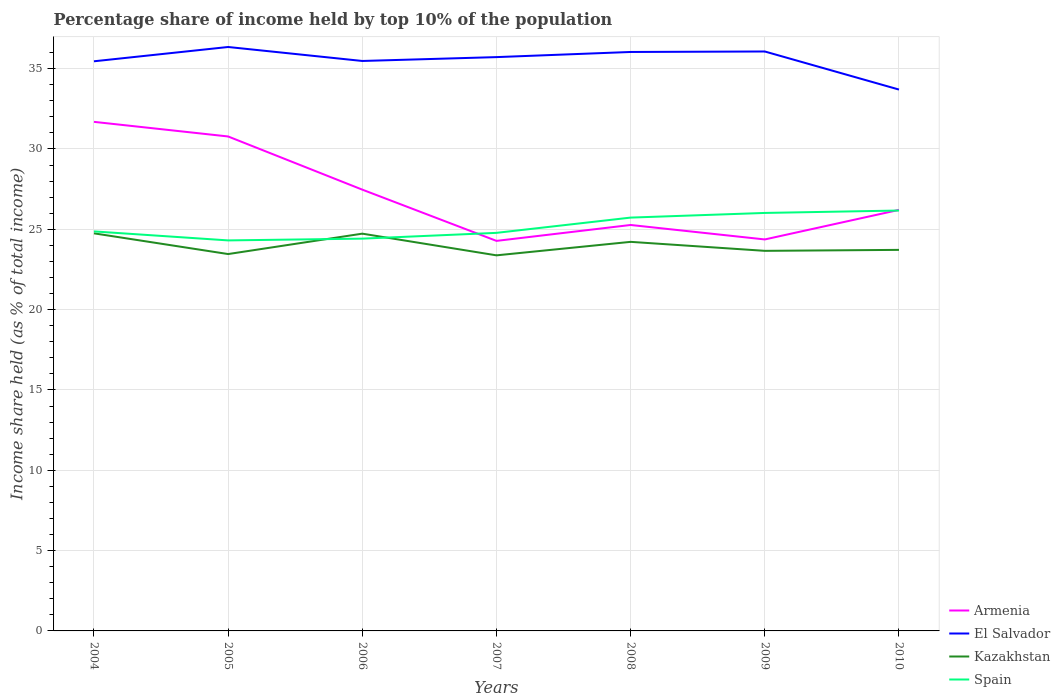How many different coloured lines are there?
Keep it short and to the point. 4. Does the line corresponding to Spain intersect with the line corresponding to El Salvador?
Provide a short and direct response. No. Is the number of lines equal to the number of legend labels?
Your answer should be very brief. Yes. Across all years, what is the maximum percentage share of income held by top 10% of the population in Spain?
Your answer should be compact. 24.31. What is the total percentage share of income held by top 10% of the population in Armenia in the graph?
Offer a very short reply. 6.5. What is the difference between the highest and the second highest percentage share of income held by top 10% of the population in El Salvador?
Make the answer very short. 2.65. What is the difference between the highest and the lowest percentage share of income held by top 10% of the population in Kazakhstan?
Your answer should be very brief. 3. How many lines are there?
Provide a succinct answer. 4. What is the difference between two consecutive major ticks on the Y-axis?
Your response must be concise. 5. Are the values on the major ticks of Y-axis written in scientific E-notation?
Provide a succinct answer. No. Does the graph contain any zero values?
Your answer should be compact. No. Does the graph contain grids?
Your response must be concise. Yes. Where does the legend appear in the graph?
Your response must be concise. Bottom right. How are the legend labels stacked?
Give a very brief answer. Vertical. What is the title of the graph?
Give a very brief answer. Percentage share of income held by top 10% of the population. Does "Small states" appear as one of the legend labels in the graph?
Provide a succinct answer. No. What is the label or title of the X-axis?
Make the answer very short. Years. What is the label or title of the Y-axis?
Keep it short and to the point. Income share held (as % of total income). What is the Income share held (as % of total income) in Armenia in 2004?
Give a very brief answer. 31.69. What is the Income share held (as % of total income) in El Salvador in 2004?
Ensure brevity in your answer.  35.46. What is the Income share held (as % of total income) of Kazakhstan in 2004?
Your response must be concise. 24.75. What is the Income share held (as % of total income) in Spain in 2004?
Offer a terse response. 24.87. What is the Income share held (as % of total income) of Armenia in 2005?
Make the answer very short. 30.78. What is the Income share held (as % of total income) in El Salvador in 2005?
Provide a short and direct response. 36.35. What is the Income share held (as % of total income) in Kazakhstan in 2005?
Make the answer very short. 23.46. What is the Income share held (as % of total income) in Spain in 2005?
Provide a short and direct response. 24.31. What is the Income share held (as % of total income) of Armenia in 2006?
Your answer should be compact. 27.47. What is the Income share held (as % of total income) in El Salvador in 2006?
Your response must be concise. 35.48. What is the Income share held (as % of total income) in Kazakhstan in 2006?
Ensure brevity in your answer.  24.73. What is the Income share held (as % of total income) of Spain in 2006?
Provide a short and direct response. 24.42. What is the Income share held (as % of total income) of Armenia in 2007?
Keep it short and to the point. 24.28. What is the Income share held (as % of total income) in El Salvador in 2007?
Ensure brevity in your answer.  35.72. What is the Income share held (as % of total income) of Kazakhstan in 2007?
Provide a succinct answer. 23.38. What is the Income share held (as % of total income) of Spain in 2007?
Provide a short and direct response. 24.78. What is the Income share held (as % of total income) in Armenia in 2008?
Keep it short and to the point. 25.27. What is the Income share held (as % of total income) in El Salvador in 2008?
Make the answer very short. 36.04. What is the Income share held (as % of total income) of Kazakhstan in 2008?
Provide a succinct answer. 24.22. What is the Income share held (as % of total income) in Spain in 2008?
Provide a short and direct response. 25.73. What is the Income share held (as % of total income) in Armenia in 2009?
Provide a short and direct response. 24.37. What is the Income share held (as % of total income) of El Salvador in 2009?
Make the answer very short. 36.07. What is the Income share held (as % of total income) of Kazakhstan in 2009?
Give a very brief answer. 23.66. What is the Income share held (as % of total income) of Spain in 2009?
Offer a terse response. 26.02. What is the Income share held (as % of total income) in Armenia in 2010?
Your response must be concise. 26.21. What is the Income share held (as % of total income) of El Salvador in 2010?
Ensure brevity in your answer.  33.7. What is the Income share held (as % of total income) in Kazakhstan in 2010?
Ensure brevity in your answer.  23.72. What is the Income share held (as % of total income) of Spain in 2010?
Your response must be concise. 26.17. Across all years, what is the maximum Income share held (as % of total income) of Armenia?
Offer a terse response. 31.69. Across all years, what is the maximum Income share held (as % of total income) of El Salvador?
Your response must be concise. 36.35. Across all years, what is the maximum Income share held (as % of total income) of Kazakhstan?
Offer a terse response. 24.75. Across all years, what is the maximum Income share held (as % of total income) in Spain?
Provide a short and direct response. 26.17. Across all years, what is the minimum Income share held (as % of total income) of Armenia?
Keep it short and to the point. 24.28. Across all years, what is the minimum Income share held (as % of total income) in El Salvador?
Provide a succinct answer. 33.7. Across all years, what is the minimum Income share held (as % of total income) of Kazakhstan?
Your answer should be compact. 23.38. Across all years, what is the minimum Income share held (as % of total income) in Spain?
Your answer should be compact. 24.31. What is the total Income share held (as % of total income) of Armenia in the graph?
Your answer should be compact. 190.07. What is the total Income share held (as % of total income) of El Salvador in the graph?
Offer a very short reply. 248.82. What is the total Income share held (as % of total income) in Kazakhstan in the graph?
Your answer should be very brief. 167.92. What is the total Income share held (as % of total income) of Spain in the graph?
Your answer should be very brief. 176.3. What is the difference between the Income share held (as % of total income) in Armenia in 2004 and that in 2005?
Your response must be concise. 0.91. What is the difference between the Income share held (as % of total income) of El Salvador in 2004 and that in 2005?
Ensure brevity in your answer.  -0.89. What is the difference between the Income share held (as % of total income) in Kazakhstan in 2004 and that in 2005?
Your answer should be compact. 1.29. What is the difference between the Income share held (as % of total income) in Spain in 2004 and that in 2005?
Offer a terse response. 0.56. What is the difference between the Income share held (as % of total income) in Armenia in 2004 and that in 2006?
Your answer should be compact. 4.22. What is the difference between the Income share held (as % of total income) of El Salvador in 2004 and that in 2006?
Ensure brevity in your answer.  -0.02. What is the difference between the Income share held (as % of total income) of Kazakhstan in 2004 and that in 2006?
Offer a very short reply. 0.02. What is the difference between the Income share held (as % of total income) in Spain in 2004 and that in 2006?
Provide a succinct answer. 0.45. What is the difference between the Income share held (as % of total income) of Armenia in 2004 and that in 2007?
Keep it short and to the point. 7.41. What is the difference between the Income share held (as % of total income) in El Salvador in 2004 and that in 2007?
Your response must be concise. -0.26. What is the difference between the Income share held (as % of total income) of Kazakhstan in 2004 and that in 2007?
Offer a very short reply. 1.37. What is the difference between the Income share held (as % of total income) in Spain in 2004 and that in 2007?
Provide a short and direct response. 0.09. What is the difference between the Income share held (as % of total income) in Armenia in 2004 and that in 2008?
Ensure brevity in your answer.  6.42. What is the difference between the Income share held (as % of total income) of El Salvador in 2004 and that in 2008?
Your answer should be compact. -0.58. What is the difference between the Income share held (as % of total income) in Kazakhstan in 2004 and that in 2008?
Ensure brevity in your answer.  0.53. What is the difference between the Income share held (as % of total income) of Spain in 2004 and that in 2008?
Your answer should be very brief. -0.86. What is the difference between the Income share held (as % of total income) of Armenia in 2004 and that in 2009?
Ensure brevity in your answer.  7.32. What is the difference between the Income share held (as % of total income) in El Salvador in 2004 and that in 2009?
Keep it short and to the point. -0.61. What is the difference between the Income share held (as % of total income) of Kazakhstan in 2004 and that in 2009?
Make the answer very short. 1.09. What is the difference between the Income share held (as % of total income) of Spain in 2004 and that in 2009?
Offer a terse response. -1.15. What is the difference between the Income share held (as % of total income) in Armenia in 2004 and that in 2010?
Your response must be concise. 5.48. What is the difference between the Income share held (as % of total income) of El Salvador in 2004 and that in 2010?
Offer a very short reply. 1.76. What is the difference between the Income share held (as % of total income) in Kazakhstan in 2004 and that in 2010?
Your answer should be very brief. 1.03. What is the difference between the Income share held (as % of total income) of Spain in 2004 and that in 2010?
Your response must be concise. -1.3. What is the difference between the Income share held (as % of total income) of Armenia in 2005 and that in 2006?
Make the answer very short. 3.31. What is the difference between the Income share held (as % of total income) in El Salvador in 2005 and that in 2006?
Your response must be concise. 0.87. What is the difference between the Income share held (as % of total income) in Kazakhstan in 2005 and that in 2006?
Ensure brevity in your answer.  -1.27. What is the difference between the Income share held (as % of total income) of Spain in 2005 and that in 2006?
Your answer should be compact. -0.11. What is the difference between the Income share held (as % of total income) of Armenia in 2005 and that in 2007?
Offer a terse response. 6.5. What is the difference between the Income share held (as % of total income) of El Salvador in 2005 and that in 2007?
Make the answer very short. 0.63. What is the difference between the Income share held (as % of total income) in Spain in 2005 and that in 2007?
Provide a short and direct response. -0.47. What is the difference between the Income share held (as % of total income) in Armenia in 2005 and that in 2008?
Your answer should be compact. 5.51. What is the difference between the Income share held (as % of total income) of El Salvador in 2005 and that in 2008?
Your response must be concise. 0.31. What is the difference between the Income share held (as % of total income) of Kazakhstan in 2005 and that in 2008?
Ensure brevity in your answer.  -0.76. What is the difference between the Income share held (as % of total income) in Spain in 2005 and that in 2008?
Provide a succinct answer. -1.42. What is the difference between the Income share held (as % of total income) in Armenia in 2005 and that in 2009?
Offer a very short reply. 6.41. What is the difference between the Income share held (as % of total income) of El Salvador in 2005 and that in 2009?
Provide a short and direct response. 0.28. What is the difference between the Income share held (as % of total income) in Spain in 2005 and that in 2009?
Your response must be concise. -1.71. What is the difference between the Income share held (as % of total income) of Armenia in 2005 and that in 2010?
Your answer should be compact. 4.57. What is the difference between the Income share held (as % of total income) in El Salvador in 2005 and that in 2010?
Your answer should be very brief. 2.65. What is the difference between the Income share held (as % of total income) of Kazakhstan in 2005 and that in 2010?
Make the answer very short. -0.26. What is the difference between the Income share held (as % of total income) of Spain in 2005 and that in 2010?
Offer a very short reply. -1.86. What is the difference between the Income share held (as % of total income) in Armenia in 2006 and that in 2007?
Your answer should be very brief. 3.19. What is the difference between the Income share held (as % of total income) of El Salvador in 2006 and that in 2007?
Provide a short and direct response. -0.24. What is the difference between the Income share held (as % of total income) in Kazakhstan in 2006 and that in 2007?
Make the answer very short. 1.35. What is the difference between the Income share held (as % of total income) of Spain in 2006 and that in 2007?
Keep it short and to the point. -0.36. What is the difference between the Income share held (as % of total income) in Armenia in 2006 and that in 2008?
Make the answer very short. 2.2. What is the difference between the Income share held (as % of total income) of El Salvador in 2006 and that in 2008?
Offer a very short reply. -0.56. What is the difference between the Income share held (as % of total income) of Kazakhstan in 2006 and that in 2008?
Your answer should be compact. 0.51. What is the difference between the Income share held (as % of total income) of Spain in 2006 and that in 2008?
Make the answer very short. -1.31. What is the difference between the Income share held (as % of total income) of El Salvador in 2006 and that in 2009?
Your answer should be compact. -0.59. What is the difference between the Income share held (as % of total income) of Kazakhstan in 2006 and that in 2009?
Offer a very short reply. 1.07. What is the difference between the Income share held (as % of total income) in Spain in 2006 and that in 2009?
Keep it short and to the point. -1.6. What is the difference between the Income share held (as % of total income) in Armenia in 2006 and that in 2010?
Provide a short and direct response. 1.26. What is the difference between the Income share held (as % of total income) of El Salvador in 2006 and that in 2010?
Give a very brief answer. 1.78. What is the difference between the Income share held (as % of total income) in Spain in 2006 and that in 2010?
Ensure brevity in your answer.  -1.75. What is the difference between the Income share held (as % of total income) of Armenia in 2007 and that in 2008?
Provide a short and direct response. -0.99. What is the difference between the Income share held (as % of total income) of El Salvador in 2007 and that in 2008?
Provide a succinct answer. -0.32. What is the difference between the Income share held (as % of total income) of Kazakhstan in 2007 and that in 2008?
Ensure brevity in your answer.  -0.84. What is the difference between the Income share held (as % of total income) of Spain in 2007 and that in 2008?
Offer a terse response. -0.95. What is the difference between the Income share held (as % of total income) in Armenia in 2007 and that in 2009?
Your answer should be very brief. -0.09. What is the difference between the Income share held (as % of total income) in El Salvador in 2007 and that in 2009?
Provide a succinct answer. -0.35. What is the difference between the Income share held (as % of total income) in Kazakhstan in 2007 and that in 2009?
Offer a terse response. -0.28. What is the difference between the Income share held (as % of total income) of Spain in 2007 and that in 2009?
Provide a short and direct response. -1.24. What is the difference between the Income share held (as % of total income) in Armenia in 2007 and that in 2010?
Your answer should be compact. -1.93. What is the difference between the Income share held (as % of total income) of El Salvador in 2007 and that in 2010?
Provide a short and direct response. 2.02. What is the difference between the Income share held (as % of total income) of Kazakhstan in 2007 and that in 2010?
Ensure brevity in your answer.  -0.34. What is the difference between the Income share held (as % of total income) in Spain in 2007 and that in 2010?
Keep it short and to the point. -1.39. What is the difference between the Income share held (as % of total income) in Armenia in 2008 and that in 2009?
Offer a very short reply. 0.9. What is the difference between the Income share held (as % of total income) of El Salvador in 2008 and that in 2009?
Your answer should be compact. -0.03. What is the difference between the Income share held (as % of total income) in Kazakhstan in 2008 and that in 2009?
Offer a very short reply. 0.56. What is the difference between the Income share held (as % of total income) of Spain in 2008 and that in 2009?
Your answer should be compact. -0.29. What is the difference between the Income share held (as % of total income) of Armenia in 2008 and that in 2010?
Provide a succinct answer. -0.94. What is the difference between the Income share held (as % of total income) of El Salvador in 2008 and that in 2010?
Ensure brevity in your answer.  2.34. What is the difference between the Income share held (as % of total income) of Spain in 2008 and that in 2010?
Offer a very short reply. -0.44. What is the difference between the Income share held (as % of total income) in Armenia in 2009 and that in 2010?
Offer a very short reply. -1.84. What is the difference between the Income share held (as % of total income) of El Salvador in 2009 and that in 2010?
Offer a very short reply. 2.37. What is the difference between the Income share held (as % of total income) in Kazakhstan in 2009 and that in 2010?
Your answer should be compact. -0.06. What is the difference between the Income share held (as % of total income) in Armenia in 2004 and the Income share held (as % of total income) in El Salvador in 2005?
Your answer should be very brief. -4.66. What is the difference between the Income share held (as % of total income) in Armenia in 2004 and the Income share held (as % of total income) in Kazakhstan in 2005?
Offer a very short reply. 8.23. What is the difference between the Income share held (as % of total income) in Armenia in 2004 and the Income share held (as % of total income) in Spain in 2005?
Ensure brevity in your answer.  7.38. What is the difference between the Income share held (as % of total income) in El Salvador in 2004 and the Income share held (as % of total income) in Spain in 2005?
Your answer should be compact. 11.15. What is the difference between the Income share held (as % of total income) in Kazakhstan in 2004 and the Income share held (as % of total income) in Spain in 2005?
Keep it short and to the point. 0.44. What is the difference between the Income share held (as % of total income) in Armenia in 2004 and the Income share held (as % of total income) in El Salvador in 2006?
Provide a short and direct response. -3.79. What is the difference between the Income share held (as % of total income) in Armenia in 2004 and the Income share held (as % of total income) in Kazakhstan in 2006?
Your response must be concise. 6.96. What is the difference between the Income share held (as % of total income) in Armenia in 2004 and the Income share held (as % of total income) in Spain in 2006?
Your answer should be compact. 7.27. What is the difference between the Income share held (as % of total income) of El Salvador in 2004 and the Income share held (as % of total income) of Kazakhstan in 2006?
Keep it short and to the point. 10.73. What is the difference between the Income share held (as % of total income) of El Salvador in 2004 and the Income share held (as % of total income) of Spain in 2006?
Your answer should be compact. 11.04. What is the difference between the Income share held (as % of total income) in Kazakhstan in 2004 and the Income share held (as % of total income) in Spain in 2006?
Provide a short and direct response. 0.33. What is the difference between the Income share held (as % of total income) of Armenia in 2004 and the Income share held (as % of total income) of El Salvador in 2007?
Your answer should be very brief. -4.03. What is the difference between the Income share held (as % of total income) in Armenia in 2004 and the Income share held (as % of total income) in Kazakhstan in 2007?
Your answer should be compact. 8.31. What is the difference between the Income share held (as % of total income) in Armenia in 2004 and the Income share held (as % of total income) in Spain in 2007?
Keep it short and to the point. 6.91. What is the difference between the Income share held (as % of total income) in El Salvador in 2004 and the Income share held (as % of total income) in Kazakhstan in 2007?
Make the answer very short. 12.08. What is the difference between the Income share held (as % of total income) in El Salvador in 2004 and the Income share held (as % of total income) in Spain in 2007?
Ensure brevity in your answer.  10.68. What is the difference between the Income share held (as % of total income) of Kazakhstan in 2004 and the Income share held (as % of total income) of Spain in 2007?
Give a very brief answer. -0.03. What is the difference between the Income share held (as % of total income) of Armenia in 2004 and the Income share held (as % of total income) of El Salvador in 2008?
Give a very brief answer. -4.35. What is the difference between the Income share held (as % of total income) in Armenia in 2004 and the Income share held (as % of total income) in Kazakhstan in 2008?
Provide a succinct answer. 7.47. What is the difference between the Income share held (as % of total income) of Armenia in 2004 and the Income share held (as % of total income) of Spain in 2008?
Keep it short and to the point. 5.96. What is the difference between the Income share held (as % of total income) in El Salvador in 2004 and the Income share held (as % of total income) in Kazakhstan in 2008?
Make the answer very short. 11.24. What is the difference between the Income share held (as % of total income) in El Salvador in 2004 and the Income share held (as % of total income) in Spain in 2008?
Offer a very short reply. 9.73. What is the difference between the Income share held (as % of total income) of Kazakhstan in 2004 and the Income share held (as % of total income) of Spain in 2008?
Offer a terse response. -0.98. What is the difference between the Income share held (as % of total income) in Armenia in 2004 and the Income share held (as % of total income) in El Salvador in 2009?
Your answer should be very brief. -4.38. What is the difference between the Income share held (as % of total income) in Armenia in 2004 and the Income share held (as % of total income) in Kazakhstan in 2009?
Keep it short and to the point. 8.03. What is the difference between the Income share held (as % of total income) of Armenia in 2004 and the Income share held (as % of total income) of Spain in 2009?
Make the answer very short. 5.67. What is the difference between the Income share held (as % of total income) of El Salvador in 2004 and the Income share held (as % of total income) of Spain in 2009?
Keep it short and to the point. 9.44. What is the difference between the Income share held (as % of total income) in Kazakhstan in 2004 and the Income share held (as % of total income) in Spain in 2009?
Offer a very short reply. -1.27. What is the difference between the Income share held (as % of total income) of Armenia in 2004 and the Income share held (as % of total income) of El Salvador in 2010?
Your answer should be compact. -2.01. What is the difference between the Income share held (as % of total income) in Armenia in 2004 and the Income share held (as % of total income) in Kazakhstan in 2010?
Give a very brief answer. 7.97. What is the difference between the Income share held (as % of total income) of Armenia in 2004 and the Income share held (as % of total income) of Spain in 2010?
Make the answer very short. 5.52. What is the difference between the Income share held (as % of total income) in El Salvador in 2004 and the Income share held (as % of total income) in Kazakhstan in 2010?
Your response must be concise. 11.74. What is the difference between the Income share held (as % of total income) of El Salvador in 2004 and the Income share held (as % of total income) of Spain in 2010?
Keep it short and to the point. 9.29. What is the difference between the Income share held (as % of total income) in Kazakhstan in 2004 and the Income share held (as % of total income) in Spain in 2010?
Give a very brief answer. -1.42. What is the difference between the Income share held (as % of total income) in Armenia in 2005 and the Income share held (as % of total income) in El Salvador in 2006?
Ensure brevity in your answer.  -4.7. What is the difference between the Income share held (as % of total income) of Armenia in 2005 and the Income share held (as % of total income) of Kazakhstan in 2006?
Offer a terse response. 6.05. What is the difference between the Income share held (as % of total income) of Armenia in 2005 and the Income share held (as % of total income) of Spain in 2006?
Keep it short and to the point. 6.36. What is the difference between the Income share held (as % of total income) in El Salvador in 2005 and the Income share held (as % of total income) in Kazakhstan in 2006?
Make the answer very short. 11.62. What is the difference between the Income share held (as % of total income) of El Salvador in 2005 and the Income share held (as % of total income) of Spain in 2006?
Offer a very short reply. 11.93. What is the difference between the Income share held (as % of total income) of Kazakhstan in 2005 and the Income share held (as % of total income) of Spain in 2006?
Make the answer very short. -0.96. What is the difference between the Income share held (as % of total income) in Armenia in 2005 and the Income share held (as % of total income) in El Salvador in 2007?
Your answer should be very brief. -4.94. What is the difference between the Income share held (as % of total income) in Armenia in 2005 and the Income share held (as % of total income) in Kazakhstan in 2007?
Make the answer very short. 7.4. What is the difference between the Income share held (as % of total income) in El Salvador in 2005 and the Income share held (as % of total income) in Kazakhstan in 2007?
Offer a very short reply. 12.97. What is the difference between the Income share held (as % of total income) in El Salvador in 2005 and the Income share held (as % of total income) in Spain in 2007?
Offer a very short reply. 11.57. What is the difference between the Income share held (as % of total income) in Kazakhstan in 2005 and the Income share held (as % of total income) in Spain in 2007?
Ensure brevity in your answer.  -1.32. What is the difference between the Income share held (as % of total income) of Armenia in 2005 and the Income share held (as % of total income) of El Salvador in 2008?
Your response must be concise. -5.26. What is the difference between the Income share held (as % of total income) of Armenia in 2005 and the Income share held (as % of total income) of Kazakhstan in 2008?
Offer a terse response. 6.56. What is the difference between the Income share held (as % of total income) in Armenia in 2005 and the Income share held (as % of total income) in Spain in 2008?
Offer a terse response. 5.05. What is the difference between the Income share held (as % of total income) in El Salvador in 2005 and the Income share held (as % of total income) in Kazakhstan in 2008?
Offer a terse response. 12.13. What is the difference between the Income share held (as % of total income) of El Salvador in 2005 and the Income share held (as % of total income) of Spain in 2008?
Offer a very short reply. 10.62. What is the difference between the Income share held (as % of total income) of Kazakhstan in 2005 and the Income share held (as % of total income) of Spain in 2008?
Give a very brief answer. -2.27. What is the difference between the Income share held (as % of total income) of Armenia in 2005 and the Income share held (as % of total income) of El Salvador in 2009?
Your response must be concise. -5.29. What is the difference between the Income share held (as % of total income) in Armenia in 2005 and the Income share held (as % of total income) in Kazakhstan in 2009?
Provide a succinct answer. 7.12. What is the difference between the Income share held (as % of total income) in Armenia in 2005 and the Income share held (as % of total income) in Spain in 2009?
Provide a succinct answer. 4.76. What is the difference between the Income share held (as % of total income) of El Salvador in 2005 and the Income share held (as % of total income) of Kazakhstan in 2009?
Ensure brevity in your answer.  12.69. What is the difference between the Income share held (as % of total income) in El Salvador in 2005 and the Income share held (as % of total income) in Spain in 2009?
Ensure brevity in your answer.  10.33. What is the difference between the Income share held (as % of total income) in Kazakhstan in 2005 and the Income share held (as % of total income) in Spain in 2009?
Give a very brief answer. -2.56. What is the difference between the Income share held (as % of total income) of Armenia in 2005 and the Income share held (as % of total income) of El Salvador in 2010?
Provide a short and direct response. -2.92. What is the difference between the Income share held (as % of total income) of Armenia in 2005 and the Income share held (as % of total income) of Kazakhstan in 2010?
Your response must be concise. 7.06. What is the difference between the Income share held (as % of total income) of Armenia in 2005 and the Income share held (as % of total income) of Spain in 2010?
Offer a very short reply. 4.61. What is the difference between the Income share held (as % of total income) of El Salvador in 2005 and the Income share held (as % of total income) of Kazakhstan in 2010?
Your answer should be compact. 12.63. What is the difference between the Income share held (as % of total income) of El Salvador in 2005 and the Income share held (as % of total income) of Spain in 2010?
Offer a terse response. 10.18. What is the difference between the Income share held (as % of total income) in Kazakhstan in 2005 and the Income share held (as % of total income) in Spain in 2010?
Give a very brief answer. -2.71. What is the difference between the Income share held (as % of total income) of Armenia in 2006 and the Income share held (as % of total income) of El Salvador in 2007?
Your response must be concise. -8.25. What is the difference between the Income share held (as % of total income) of Armenia in 2006 and the Income share held (as % of total income) of Kazakhstan in 2007?
Provide a succinct answer. 4.09. What is the difference between the Income share held (as % of total income) in Armenia in 2006 and the Income share held (as % of total income) in Spain in 2007?
Offer a very short reply. 2.69. What is the difference between the Income share held (as % of total income) of El Salvador in 2006 and the Income share held (as % of total income) of Spain in 2007?
Your answer should be compact. 10.7. What is the difference between the Income share held (as % of total income) in Kazakhstan in 2006 and the Income share held (as % of total income) in Spain in 2007?
Offer a very short reply. -0.05. What is the difference between the Income share held (as % of total income) in Armenia in 2006 and the Income share held (as % of total income) in El Salvador in 2008?
Your answer should be compact. -8.57. What is the difference between the Income share held (as % of total income) in Armenia in 2006 and the Income share held (as % of total income) in Kazakhstan in 2008?
Offer a very short reply. 3.25. What is the difference between the Income share held (as % of total income) in Armenia in 2006 and the Income share held (as % of total income) in Spain in 2008?
Provide a succinct answer. 1.74. What is the difference between the Income share held (as % of total income) of El Salvador in 2006 and the Income share held (as % of total income) of Kazakhstan in 2008?
Your response must be concise. 11.26. What is the difference between the Income share held (as % of total income) in El Salvador in 2006 and the Income share held (as % of total income) in Spain in 2008?
Offer a very short reply. 9.75. What is the difference between the Income share held (as % of total income) of Armenia in 2006 and the Income share held (as % of total income) of El Salvador in 2009?
Give a very brief answer. -8.6. What is the difference between the Income share held (as % of total income) of Armenia in 2006 and the Income share held (as % of total income) of Kazakhstan in 2009?
Give a very brief answer. 3.81. What is the difference between the Income share held (as % of total income) of Armenia in 2006 and the Income share held (as % of total income) of Spain in 2009?
Your response must be concise. 1.45. What is the difference between the Income share held (as % of total income) of El Salvador in 2006 and the Income share held (as % of total income) of Kazakhstan in 2009?
Provide a succinct answer. 11.82. What is the difference between the Income share held (as % of total income) of El Salvador in 2006 and the Income share held (as % of total income) of Spain in 2009?
Provide a short and direct response. 9.46. What is the difference between the Income share held (as % of total income) of Kazakhstan in 2006 and the Income share held (as % of total income) of Spain in 2009?
Keep it short and to the point. -1.29. What is the difference between the Income share held (as % of total income) of Armenia in 2006 and the Income share held (as % of total income) of El Salvador in 2010?
Your answer should be compact. -6.23. What is the difference between the Income share held (as % of total income) of Armenia in 2006 and the Income share held (as % of total income) of Kazakhstan in 2010?
Your response must be concise. 3.75. What is the difference between the Income share held (as % of total income) of El Salvador in 2006 and the Income share held (as % of total income) of Kazakhstan in 2010?
Offer a very short reply. 11.76. What is the difference between the Income share held (as % of total income) of El Salvador in 2006 and the Income share held (as % of total income) of Spain in 2010?
Give a very brief answer. 9.31. What is the difference between the Income share held (as % of total income) of Kazakhstan in 2006 and the Income share held (as % of total income) of Spain in 2010?
Your response must be concise. -1.44. What is the difference between the Income share held (as % of total income) of Armenia in 2007 and the Income share held (as % of total income) of El Salvador in 2008?
Offer a terse response. -11.76. What is the difference between the Income share held (as % of total income) in Armenia in 2007 and the Income share held (as % of total income) in Spain in 2008?
Offer a terse response. -1.45. What is the difference between the Income share held (as % of total income) in El Salvador in 2007 and the Income share held (as % of total income) in Spain in 2008?
Your answer should be compact. 9.99. What is the difference between the Income share held (as % of total income) in Kazakhstan in 2007 and the Income share held (as % of total income) in Spain in 2008?
Your answer should be compact. -2.35. What is the difference between the Income share held (as % of total income) in Armenia in 2007 and the Income share held (as % of total income) in El Salvador in 2009?
Make the answer very short. -11.79. What is the difference between the Income share held (as % of total income) in Armenia in 2007 and the Income share held (as % of total income) in Kazakhstan in 2009?
Keep it short and to the point. 0.62. What is the difference between the Income share held (as % of total income) in Armenia in 2007 and the Income share held (as % of total income) in Spain in 2009?
Offer a very short reply. -1.74. What is the difference between the Income share held (as % of total income) of El Salvador in 2007 and the Income share held (as % of total income) of Kazakhstan in 2009?
Offer a terse response. 12.06. What is the difference between the Income share held (as % of total income) in El Salvador in 2007 and the Income share held (as % of total income) in Spain in 2009?
Your answer should be very brief. 9.7. What is the difference between the Income share held (as % of total income) in Kazakhstan in 2007 and the Income share held (as % of total income) in Spain in 2009?
Your answer should be very brief. -2.64. What is the difference between the Income share held (as % of total income) of Armenia in 2007 and the Income share held (as % of total income) of El Salvador in 2010?
Provide a succinct answer. -9.42. What is the difference between the Income share held (as % of total income) of Armenia in 2007 and the Income share held (as % of total income) of Kazakhstan in 2010?
Provide a succinct answer. 0.56. What is the difference between the Income share held (as % of total income) of Armenia in 2007 and the Income share held (as % of total income) of Spain in 2010?
Give a very brief answer. -1.89. What is the difference between the Income share held (as % of total income) in El Salvador in 2007 and the Income share held (as % of total income) in Kazakhstan in 2010?
Make the answer very short. 12. What is the difference between the Income share held (as % of total income) in El Salvador in 2007 and the Income share held (as % of total income) in Spain in 2010?
Give a very brief answer. 9.55. What is the difference between the Income share held (as % of total income) of Kazakhstan in 2007 and the Income share held (as % of total income) of Spain in 2010?
Keep it short and to the point. -2.79. What is the difference between the Income share held (as % of total income) in Armenia in 2008 and the Income share held (as % of total income) in El Salvador in 2009?
Your answer should be compact. -10.8. What is the difference between the Income share held (as % of total income) of Armenia in 2008 and the Income share held (as % of total income) of Kazakhstan in 2009?
Provide a succinct answer. 1.61. What is the difference between the Income share held (as % of total income) of Armenia in 2008 and the Income share held (as % of total income) of Spain in 2009?
Offer a terse response. -0.75. What is the difference between the Income share held (as % of total income) of El Salvador in 2008 and the Income share held (as % of total income) of Kazakhstan in 2009?
Offer a very short reply. 12.38. What is the difference between the Income share held (as % of total income) of El Salvador in 2008 and the Income share held (as % of total income) of Spain in 2009?
Offer a very short reply. 10.02. What is the difference between the Income share held (as % of total income) in Kazakhstan in 2008 and the Income share held (as % of total income) in Spain in 2009?
Your response must be concise. -1.8. What is the difference between the Income share held (as % of total income) in Armenia in 2008 and the Income share held (as % of total income) in El Salvador in 2010?
Ensure brevity in your answer.  -8.43. What is the difference between the Income share held (as % of total income) of Armenia in 2008 and the Income share held (as % of total income) of Kazakhstan in 2010?
Provide a succinct answer. 1.55. What is the difference between the Income share held (as % of total income) of Armenia in 2008 and the Income share held (as % of total income) of Spain in 2010?
Your answer should be compact. -0.9. What is the difference between the Income share held (as % of total income) of El Salvador in 2008 and the Income share held (as % of total income) of Kazakhstan in 2010?
Offer a terse response. 12.32. What is the difference between the Income share held (as % of total income) in El Salvador in 2008 and the Income share held (as % of total income) in Spain in 2010?
Your answer should be compact. 9.87. What is the difference between the Income share held (as % of total income) in Kazakhstan in 2008 and the Income share held (as % of total income) in Spain in 2010?
Your answer should be compact. -1.95. What is the difference between the Income share held (as % of total income) of Armenia in 2009 and the Income share held (as % of total income) of El Salvador in 2010?
Keep it short and to the point. -9.33. What is the difference between the Income share held (as % of total income) of Armenia in 2009 and the Income share held (as % of total income) of Kazakhstan in 2010?
Ensure brevity in your answer.  0.65. What is the difference between the Income share held (as % of total income) of Armenia in 2009 and the Income share held (as % of total income) of Spain in 2010?
Keep it short and to the point. -1.8. What is the difference between the Income share held (as % of total income) in El Salvador in 2009 and the Income share held (as % of total income) in Kazakhstan in 2010?
Your answer should be very brief. 12.35. What is the difference between the Income share held (as % of total income) in Kazakhstan in 2009 and the Income share held (as % of total income) in Spain in 2010?
Ensure brevity in your answer.  -2.51. What is the average Income share held (as % of total income) of Armenia per year?
Make the answer very short. 27.15. What is the average Income share held (as % of total income) in El Salvador per year?
Offer a terse response. 35.55. What is the average Income share held (as % of total income) in Kazakhstan per year?
Provide a succinct answer. 23.99. What is the average Income share held (as % of total income) of Spain per year?
Your answer should be compact. 25.19. In the year 2004, what is the difference between the Income share held (as % of total income) of Armenia and Income share held (as % of total income) of El Salvador?
Ensure brevity in your answer.  -3.77. In the year 2004, what is the difference between the Income share held (as % of total income) of Armenia and Income share held (as % of total income) of Kazakhstan?
Your answer should be very brief. 6.94. In the year 2004, what is the difference between the Income share held (as % of total income) of Armenia and Income share held (as % of total income) of Spain?
Provide a short and direct response. 6.82. In the year 2004, what is the difference between the Income share held (as % of total income) of El Salvador and Income share held (as % of total income) of Kazakhstan?
Offer a very short reply. 10.71. In the year 2004, what is the difference between the Income share held (as % of total income) in El Salvador and Income share held (as % of total income) in Spain?
Ensure brevity in your answer.  10.59. In the year 2004, what is the difference between the Income share held (as % of total income) in Kazakhstan and Income share held (as % of total income) in Spain?
Your answer should be very brief. -0.12. In the year 2005, what is the difference between the Income share held (as % of total income) of Armenia and Income share held (as % of total income) of El Salvador?
Offer a terse response. -5.57. In the year 2005, what is the difference between the Income share held (as % of total income) of Armenia and Income share held (as % of total income) of Kazakhstan?
Offer a very short reply. 7.32. In the year 2005, what is the difference between the Income share held (as % of total income) of Armenia and Income share held (as % of total income) of Spain?
Keep it short and to the point. 6.47. In the year 2005, what is the difference between the Income share held (as % of total income) of El Salvador and Income share held (as % of total income) of Kazakhstan?
Your answer should be compact. 12.89. In the year 2005, what is the difference between the Income share held (as % of total income) in El Salvador and Income share held (as % of total income) in Spain?
Provide a succinct answer. 12.04. In the year 2005, what is the difference between the Income share held (as % of total income) in Kazakhstan and Income share held (as % of total income) in Spain?
Ensure brevity in your answer.  -0.85. In the year 2006, what is the difference between the Income share held (as % of total income) in Armenia and Income share held (as % of total income) in El Salvador?
Your response must be concise. -8.01. In the year 2006, what is the difference between the Income share held (as % of total income) in Armenia and Income share held (as % of total income) in Kazakhstan?
Ensure brevity in your answer.  2.74. In the year 2006, what is the difference between the Income share held (as % of total income) of Armenia and Income share held (as % of total income) of Spain?
Offer a terse response. 3.05. In the year 2006, what is the difference between the Income share held (as % of total income) of El Salvador and Income share held (as % of total income) of Kazakhstan?
Give a very brief answer. 10.75. In the year 2006, what is the difference between the Income share held (as % of total income) in El Salvador and Income share held (as % of total income) in Spain?
Make the answer very short. 11.06. In the year 2006, what is the difference between the Income share held (as % of total income) of Kazakhstan and Income share held (as % of total income) of Spain?
Offer a very short reply. 0.31. In the year 2007, what is the difference between the Income share held (as % of total income) in Armenia and Income share held (as % of total income) in El Salvador?
Keep it short and to the point. -11.44. In the year 2007, what is the difference between the Income share held (as % of total income) of Armenia and Income share held (as % of total income) of Kazakhstan?
Give a very brief answer. 0.9. In the year 2007, what is the difference between the Income share held (as % of total income) in El Salvador and Income share held (as % of total income) in Kazakhstan?
Give a very brief answer. 12.34. In the year 2007, what is the difference between the Income share held (as % of total income) of El Salvador and Income share held (as % of total income) of Spain?
Provide a short and direct response. 10.94. In the year 2007, what is the difference between the Income share held (as % of total income) of Kazakhstan and Income share held (as % of total income) of Spain?
Provide a short and direct response. -1.4. In the year 2008, what is the difference between the Income share held (as % of total income) in Armenia and Income share held (as % of total income) in El Salvador?
Keep it short and to the point. -10.77. In the year 2008, what is the difference between the Income share held (as % of total income) in Armenia and Income share held (as % of total income) in Kazakhstan?
Your answer should be very brief. 1.05. In the year 2008, what is the difference between the Income share held (as % of total income) of Armenia and Income share held (as % of total income) of Spain?
Give a very brief answer. -0.46. In the year 2008, what is the difference between the Income share held (as % of total income) in El Salvador and Income share held (as % of total income) in Kazakhstan?
Provide a short and direct response. 11.82. In the year 2008, what is the difference between the Income share held (as % of total income) of El Salvador and Income share held (as % of total income) of Spain?
Your answer should be very brief. 10.31. In the year 2008, what is the difference between the Income share held (as % of total income) in Kazakhstan and Income share held (as % of total income) in Spain?
Ensure brevity in your answer.  -1.51. In the year 2009, what is the difference between the Income share held (as % of total income) of Armenia and Income share held (as % of total income) of Kazakhstan?
Offer a terse response. 0.71. In the year 2009, what is the difference between the Income share held (as % of total income) of Armenia and Income share held (as % of total income) of Spain?
Provide a succinct answer. -1.65. In the year 2009, what is the difference between the Income share held (as % of total income) of El Salvador and Income share held (as % of total income) of Kazakhstan?
Offer a very short reply. 12.41. In the year 2009, what is the difference between the Income share held (as % of total income) in El Salvador and Income share held (as % of total income) in Spain?
Your answer should be very brief. 10.05. In the year 2009, what is the difference between the Income share held (as % of total income) of Kazakhstan and Income share held (as % of total income) of Spain?
Offer a terse response. -2.36. In the year 2010, what is the difference between the Income share held (as % of total income) of Armenia and Income share held (as % of total income) of El Salvador?
Your response must be concise. -7.49. In the year 2010, what is the difference between the Income share held (as % of total income) of Armenia and Income share held (as % of total income) of Kazakhstan?
Provide a short and direct response. 2.49. In the year 2010, what is the difference between the Income share held (as % of total income) of El Salvador and Income share held (as % of total income) of Kazakhstan?
Give a very brief answer. 9.98. In the year 2010, what is the difference between the Income share held (as % of total income) in El Salvador and Income share held (as % of total income) in Spain?
Offer a very short reply. 7.53. In the year 2010, what is the difference between the Income share held (as % of total income) of Kazakhstan and Income share held (as % of total income) of Spain?
Your answer should be compact. -2.45. What is the ratio of the Income share held (as % of total income) in Armenia in 2004 to that in 2005?
Your answer should be very brief. 1.03. What is the ratio of the Income share held (as % of total income) of El Salvador in 2004 to that in 2005?
Give a very brief answer. 0.98. What is the ratio of the Income share held (as % of total income) in Kazakhstan in 2004 to that in 2005?
Give a very brief answer. 1.05. What is the ratio of the Income share held (as % of total income) of Armenia in 2004 to that in 2006?
Offer a terse response. 1.15. What is the ratio of the Income share held (as % of total income) of Spain in 2004 to that in 2006?
Provide a short and direct response. 1.02. What is the ratio of the Income share held (as % of total income) of Armenia in 2004 to that in 2007?
Provide a short and direct response. 1.31. What is the ratio of the Income share held (as % of total income) of Kazakhstan in 2004 to that in 2007?
Offer a terse response. 1.06. What is the ratio of the Income share held (as % of total income) of Spain in 2004 to that in 2007?
Provide a short and direct response. 1. What is the ratio of the Income share held (as % of total income) in Armenia in 2004 to that in 2008?
Your answer should be compact. 1.25. What is the ratio of the Income share held (as % of total income) of El Salvador in 2004 to that in 2008?
Offer a terse response. 0.98. What is the ratio of the Income share held (as % of total income) of Kazakhstan in 2004 to that in 2008?
Provide a short and direct response. 1.02. What is the ratio of the Income share held (as % of total income) of Spain in 2004 to that in 2008?
Provide a short and direct response. 0.97. What is the ratio of the Income share held (as % of total income) in Armenia in 2004 to that in 2009?
Make the answer very short. 1.3. What is the ratio of the Income share held (as % of total income) of El Salvador in 2004 to that in 2009?
Your answer should be compact. 0.98. What is the ratio of the Income share held (as % of total income) in Kazakhstan in 2004 to that in 2009?
Your answer should be very brief. 1.05. What is the ratio of the Income share held (as % of total income) in Spain in 2004 to that in 2009?
Your response must be concise. 0.96. What is the ratio of the Income share held (as % of total income) in Armenia in 2004 to that in 2010?
Give a very brief answer. 1.21. What is the ratio of the Income share held (as % of total income) of El Salvador in 2004 to that in 2010?
Your response must be concise. 1.05. What is the ratio of the Income share held (as % of total income) in Kazakhstan in 2004 to that in 2010?
Offer a very short reply. 1.04. What is the ratio of the Income share held (as % of total income) of Spain in 2004 to that in 2010?
Offer a terse response. 0.95. What is the ratio of the Income share held (as % of total income) of Armenia in 2005 to that in 2006?
Provide a short and direct response. 1.12. What is the ratio of the Income share held (as % of total income) in El Salvador in 2005 to that in 2006?
Provide a short and direct response. 1.02. What is the ratio of the Income share held (as % of total income) in Kazakhstan in 2005 to that in 2006?
Provide a succinct answer. 0.95. What is the ratio of the Income share held (as % of total income) in Armenia in 2005 to that in 2007?
Make the answer very short. 1.27. What is the ratio of the Income share held (as % of total income) in El Salvador in 2005 to that in 2007?
Offer a very short reply. 1.02. What is the ratio of the Income share held (as % of total income) of Kazakhstan in 2005 to that in 2007?
Make the answer very short. 1. What is the ratio of the Income share held (as % of total income) of Spain in 2005 to that in 2007?
Provide a short and direct response. 0.98. What is the ratio of the Income share held (as % of total income) of Armenia in 2005 to that in 2008?
Give a very brief answer. 1.22. What is the ratio of the Income share held (as % of total income) of El Salvador in 2005 to that in 2008?
Give a very brief answer. 1.01. What is the ratio of the Income share held (as % of total income) in Kazakhstan in 2005 to that in 2008?
Keep it short and to the point. 0.97. What is the ratio of the Income share held (as % of total income) of Spain in 2005 to that in 2008?
Ensure brevity in your answer.  0.94. What is the ratio of the Income share held (as % of total income) in Armenia in 2005 to that in 2009?
Provide a short and direct response. 1.26. What is the ratio of the Income share held (as % of total income) of Kazakhstan in 2005 to that in 2009?
Keep it short and to the point. 0.99. What is the ratio of the Income share held (as % of total income) of Spain in 2005 to that in 2009?
Ensure brevity in your answer.  0.93. What is the ratio of the Income share held (as % of total income) of Armenia in 2005 to that in 2010?
Give a very brief answer. 1.17. What is the ratio of the Income share held (as % of total income) in El Salvador in 2005 to that in 2010?
Give a very brief answer. 1.08. What is the ratio of the Income share held (as % of total income) in Kazakhstan in 2005 to that in 2010?
Offer a terse response. 0.99. What is the ratio of the Income share held (as % of total income) of Spain in 2005 to that in 2010?
Provide a succinct answer. 0.93. What is the ratio of the Income share held (as % of total income) of Armenia in 2006 to that in 2007?
Provide a succinct answer. 1.13. What is the ratio of the Income share held (as % of total income) in Kazakhstan in 2006 to that in 2007?
Your answer should be very brief. 1.06. What is the ratio of the Income share held (as % of total income) in Spain in 2006 to that in 2007?
Give a very brief answer. 0.99. What is the ratio of the Income share held (as % of total income) in Armenia in 2006 to that in 2008?
Ensure brevity in your answer.  1.09. What is the ratio of the Income share held (as % of total income) of El Salvador in 2006 to that in 2008?
Your answer should be compact. 0.98. What is the ratio of the Income share held (as % of total income) of Kazakhstan in 2006 to that in 2008?
Keep it short and to the point. 1.02. What is the ratio of the Income share held (as % of total income) of Spain in 2006 to that in 2008?
Your answer should be very brief. 0.95. What is the ratio of the Income share held (as % of total income) of Armenia in 2006 to that in 2009?
Give a very brief answer. 1.13. What is the ratio of the Income share held (as % of total income) in El Salvador in 2006 to that in 2009?
Offer a terse response. 0.98. What is the ratio of the Income share held (as % of total income) in Kazakhstan in 2006 to that in 2009?
Your response must be concise. 1.05. What is the ratio of the Income share held (as % of total income) of Spain in 2006 to that in 2009?
Make the answer very short. 0.94. What is the ratio of the Income share held (as % of total income) in Armenia in 2006 to that in 2010?
Ensure brevity in your answer.  1.05. What is the ratio of the Income share held (as % of total income) of El Salvador in 2006 to that in 2010?
Ensure brevity in your answer.  1.05. What is the ratio of the Income share held (as % of total income) in Kazakhstan in 2006 to that in 2010?
Your response must be concise. 1.04. What is the ratio of the Income share held (as % of total income) of Spain in 2006 to that in 2010?
Give a very brief answer. 0.93. What is the ratio of the Income share held (as % of total income) in Armenia in 2007 to that in 2008?
Keep it short and to the point. 0.96. What is the ratio of the Income share held (as % of total income) of El Salvador in 2007 to that in 2008?
Your answer should be very brief. 0.99. What is the ratio of the Income share held (as % of total income) in Kazakhstan in 2007 to that in 2008?
Make the answer very short. 0.97. What is the ratio of the Income share held (as % of total income) in Spain in 2007 to that in 2008?
Ensure brevity in your answer.  0.96. What is the ratio of the Income share held (as % of total income) in Armenia in 2007 to that in 2009?
Your response must be concise. 1. What is the ratio of the Income share held (as % of total income) of El Salvador in 2007 to that in 2009?
Offer a terse response. 0.99. What is the ratio of the Income share held (as % of total income) in Spain in 2007 to that in 2009?
Give a very brief answer. 0.95. What is the ratio of the Income share held (as % of total income) in Armenia in 2007 to that in 2010?
Offer a very short reply. 0.93. What is the ratio of the Income share held (as % of total income) in El Salvador in 2007 to that in 2010?
Your answer should be compact. 1.06. What is the ratio of the Income share held (as % of total income) in Kazakhstan in 2007 to that in 2010?
Ensure brevity in your answer.  0.99. What is the ratio of the Income share held (as % of total income) in Spain in 2007 to that in 2010?
Provide a succinct answer. 0.95. What is the ratio of the Income share held (as % of total income) in Armenia in 2008 to that in 2009?
Ensure brevity in your answer.  1.04. What is the ratio of the Income share held (as % of total income) in El Salvador in 2008 to that in 2009?
Provide a succinct answer. 1. What is the ratio of the Income share held (as % of total income) of Kazakhstan in 2008 to that in 2009?
Ensure brevity in your answer.  1.02. What is the ratio of the Income share held (as % of total income) of Spain in 2008 to that in 2009?
Give a very brief answer. 0.99. What is the ratio of the Income share held (as % of total income) of Armenia in 2008 to that in 2010?
Your answer should be compact. 0.96. What is the ratio of the Income share held (as % of total income) in El Salvador in 2008 to that in 2010?
Your response must be concise. 1.07. What is the ratio of the Income share held (as % of total income) of Kazakhstan in 2008 to that in 2010?
Keep it short and to the point. 1.02. What is the ratio of the Income share held (as % of total income) of Spain in 2008 to that in 2010?
Ensure brevity in your answer.  0.98. What is the ratio of the Income share held (as % of total income) in Armenia in 2009 to that in 2010?
Make the answer very short. 0.93. What is the ratio of the Income share held (as % of total income) of El Salvador in 2009 to that in 2010?
Provide a short and direct response. 1.07. What is the ratio of the Income share held (as % of total income) of Spain in 2009 to that in 2010?
Provide a short and direct response. 0.99. What is the difference between the highest and the second highest Income share held (as % of total income) in Armenia?
Your response must be concise. 0.91. What is the difference between the highest and the second highest Income share held (as % of total income) in El Salvador?
Give a very brief answer. 0.28. What is the difference between the highest and the second highest Income share held (as % of total income) of Kazakhstan?
Your answer should be very brief. 0.02. What is the difference between the highest and the lowest Income share held (as % of total income) in Armenia?
Give a very brief answer. 7.41. What is the difference between the highest and the lowest Income share held (as % of total income) in El Salvador?
Your response must be concise. 2.65. What is the difference between the highest and the lowest Income share held (as % of total income) of Kazakhstan?
Offer a very short reply. 1.37. What is the difference between the highest and the lowest Income share held (as % of total income) of Spain?
Make the answer very short. 1.86. 